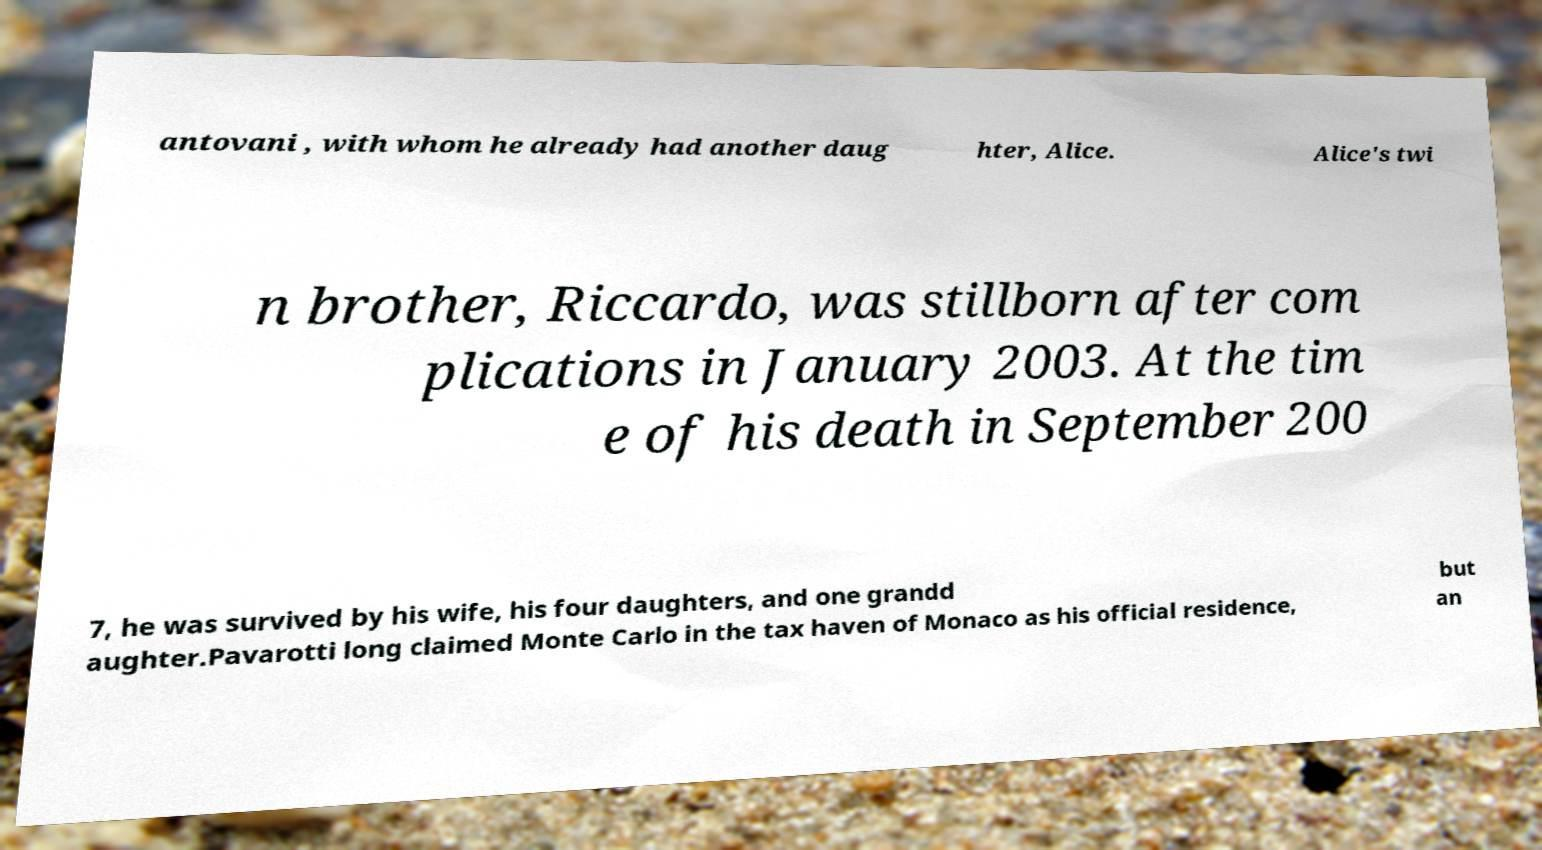I need the written content from this picture converted into text. Can you do that? antovani , with whom he already had another daug hter, Alice. Alice's twi n brother, Riccardo, was stillborn after com plications in January 2003. At the tim e of his death in September 200 7, he was survived by his wife, his four daughters, and one grandd aughter.Pavarotti long claimed Monte Carlo in the tax haven of Monaco as his official residence, but an 